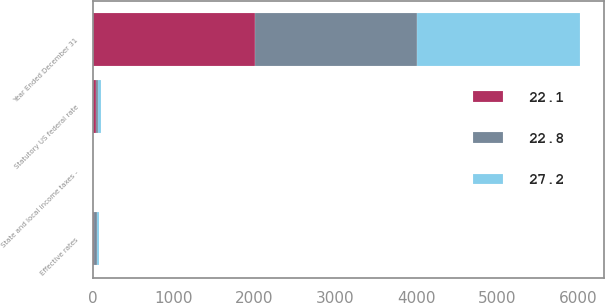Convert chart. <chart><loc_0><loc_0><loc_500><loc_500><stacked_bar_chart><ecel><fcel>Year Ended December 31<fcel>Statutory US federal rate<fcel>State and local income taxes -<fcel>Effective rates<nl><fcel>27.2<fcel>2006<fcel>35<fcel>0.7<fcel>22.8<nl><fcel>22.8<fcel>2005<fcel>35<fcel>1.2<fcel>27.2<nl><fcel>22.1<fcel>2004<fcel>35<fcel>1<fcel>22.1<nl></chart> 